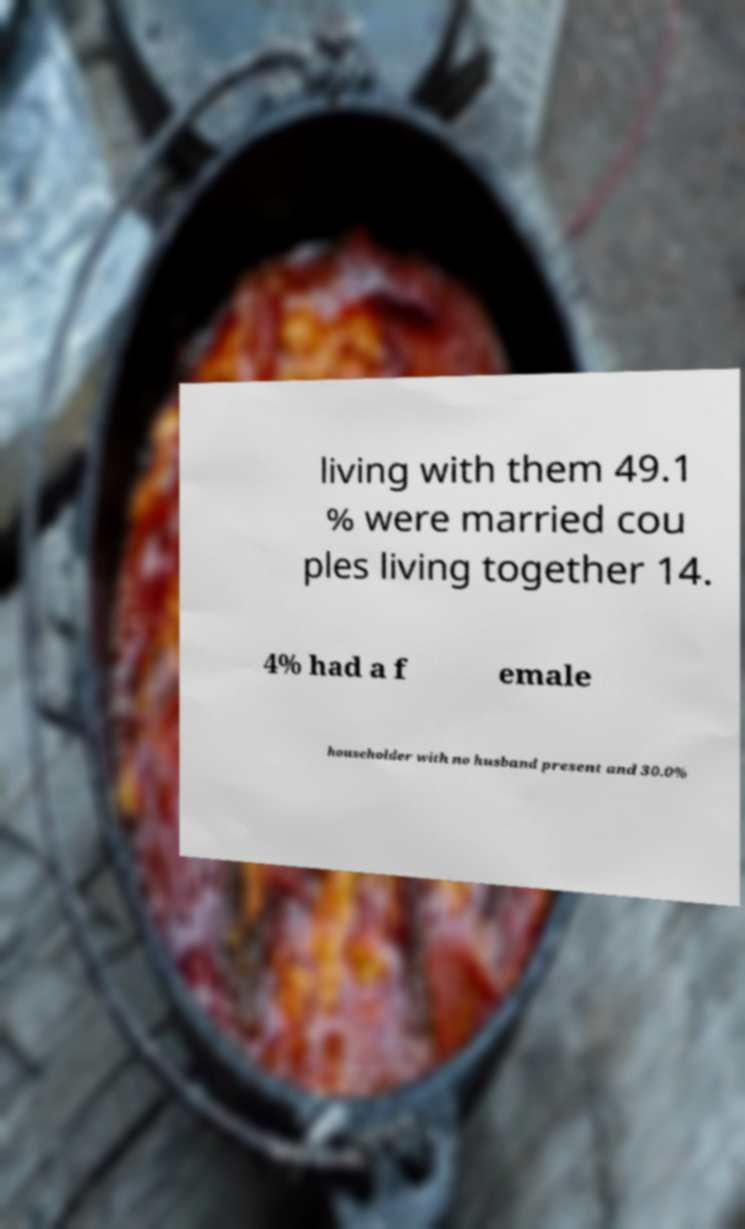What messages or text are displayed in this image? I need them in a readable, typed format. living with them 49.1 % were married cou ples living together 14. 4% had a f emale householder with no husband present and 30.0% 